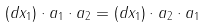<formula> <loc_0><loc_0><loc_500><loc_500>( d x _ { 1 } ) \cdot a _ { 1 } \cdot a _ { 2 } = ( d x _ { 1 } ) \cdot a _ { 2 } \cdot a _ { 1 }</formula> 